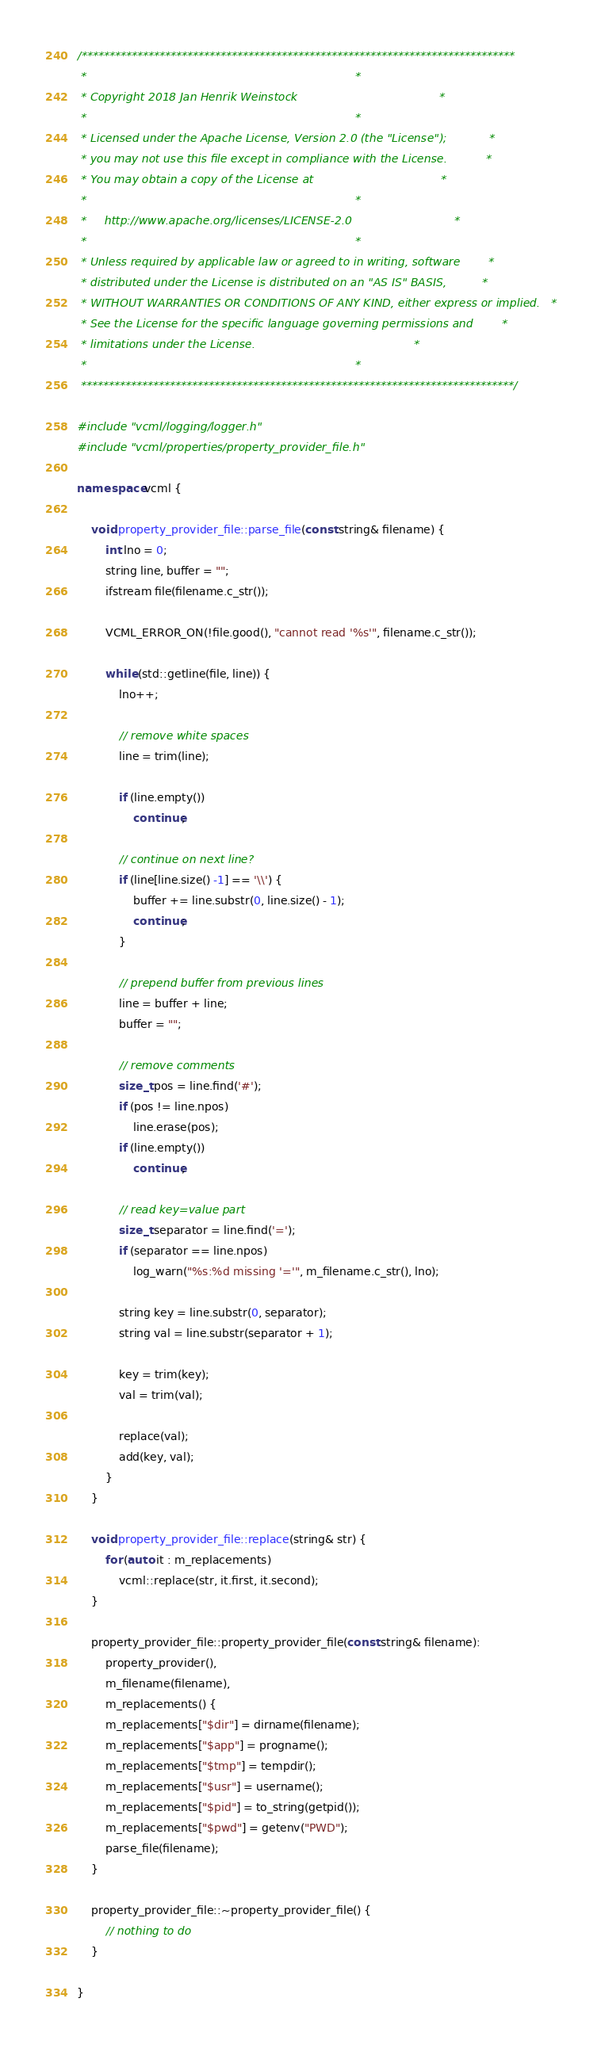<code> <loc_0><loc_0><loc_500><loc_500><_C++_>/******************************************************************************
 *                                                                            *
 * Copyright 2018 Jan Henrik Weinstock                                        *
 *                                                                            *
 * Licensed under the Apache License, Version 2.0 (the "License");            *
 * you may not use this file except in compliance with the License.           *
 * You may obtain a copy of the License at                                    *
 *                                                                            *
 *     http://www.apache.org/licenses/LICENSE-2.0                             *
 *                                                                            *
 * Unless required by applicable law or agreed to in writing, software        *
 * distributed under the License is distributed on an "AS IS" BASIS,          *
 * WITHOUT WARRANTIES OR CONDITIONS OF ANY KIND, either express or implied.   *
 * See the License for the specific language governing permissions and        *
 * limitations under the License.                                             *
 *                                                                            *
 ******************************************************************************/

#include "vcml/logging/logger.h"
#include "vcml/properties/property_provider_file.h"

namespace vcml {

    void property_provider_file::parse_file(const string& filename) {
        int lno = 0;
        string line, buffer = "";
        ifstream file(filename.c_str());

        VCML_ERROR_ON(!file.good(), "cannot read '%s'", filename.c_str());

        while (std::getline(file, line)) {
            lno++;

            // remove white spaces
            line = trim(line);

            if (line.empty())
                continue;

            // continue on next line?
            if (line[line.size() -1] == '\\') {
                buffer += line.substr(0, line.size() - 1);
                continue;
            }

            // prepend buffer from previous lines
            line = buffer + line;
            buffer = "";

            // remove comments
            size_t pos = line.find('#');
            if (pos != line.npos)
                line.erase(pos);
            if (line.empty())
                continue;

            // read key=value part
            size_t separator = line.find('=');
            if (separator == line.npos)
                log_warn("%s:%d missing '='", m_filename.c_str(), lno);

            string key = line.substr(0, separator);
            string val = line.substr(separator + 1);

            key = trim(key);
            val = trim(val);

            replace(val);
            add(key, val);
        }
    }

    void property_provider_file::replace(string& str) {
        for (auto it : m_replacements)
            vcml::replace(str, it.first, it.second);
    }

    property_provider_file::property_provider_file(const string& filename):
        property_provider(),
        m_filename(filename),
        m_replacements() {
        m_replacements["$dir"] = dirname(filename);
        m_replacements["$app"] = progname();
        m_replacements["$tmp"] = tempdir();
        m_replacements["$usr"] = username();
        m_replacements["$pid"] = to_string(getpid());
        m_replacements["$pwd"] = getenv("PWD");
        parse_file(filename);
    }

    property_provider_file::~property_provider_file() {
        // nothing to do
    }

}
</code> 